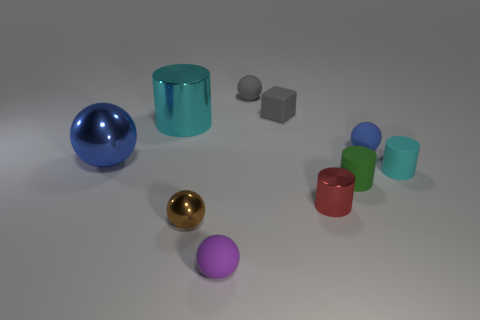Subtract 1 spheres. How many spheres are left? 4 Subtract all yellow balls. Subtract all purple cubes. How many balls are left? 5 Subtract all blocks. How many objects are left? 9 Add 9 tiny matte cubes. How many tiny matte cubes are left? 10 Add 2 purple matte objects. How many purple matte objects exist? 3 Subtract 0 cyan balls. How many objects are left? 10 Subtract all big cyan rubber cubes. Subtract all brown balls. How many objects are left? 9 